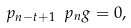<formula> <loc_0><loc_0><loc_500><loc_500>\ p _ { n - t + 1 } \ p _ { n } g = 0 ,</formula> 